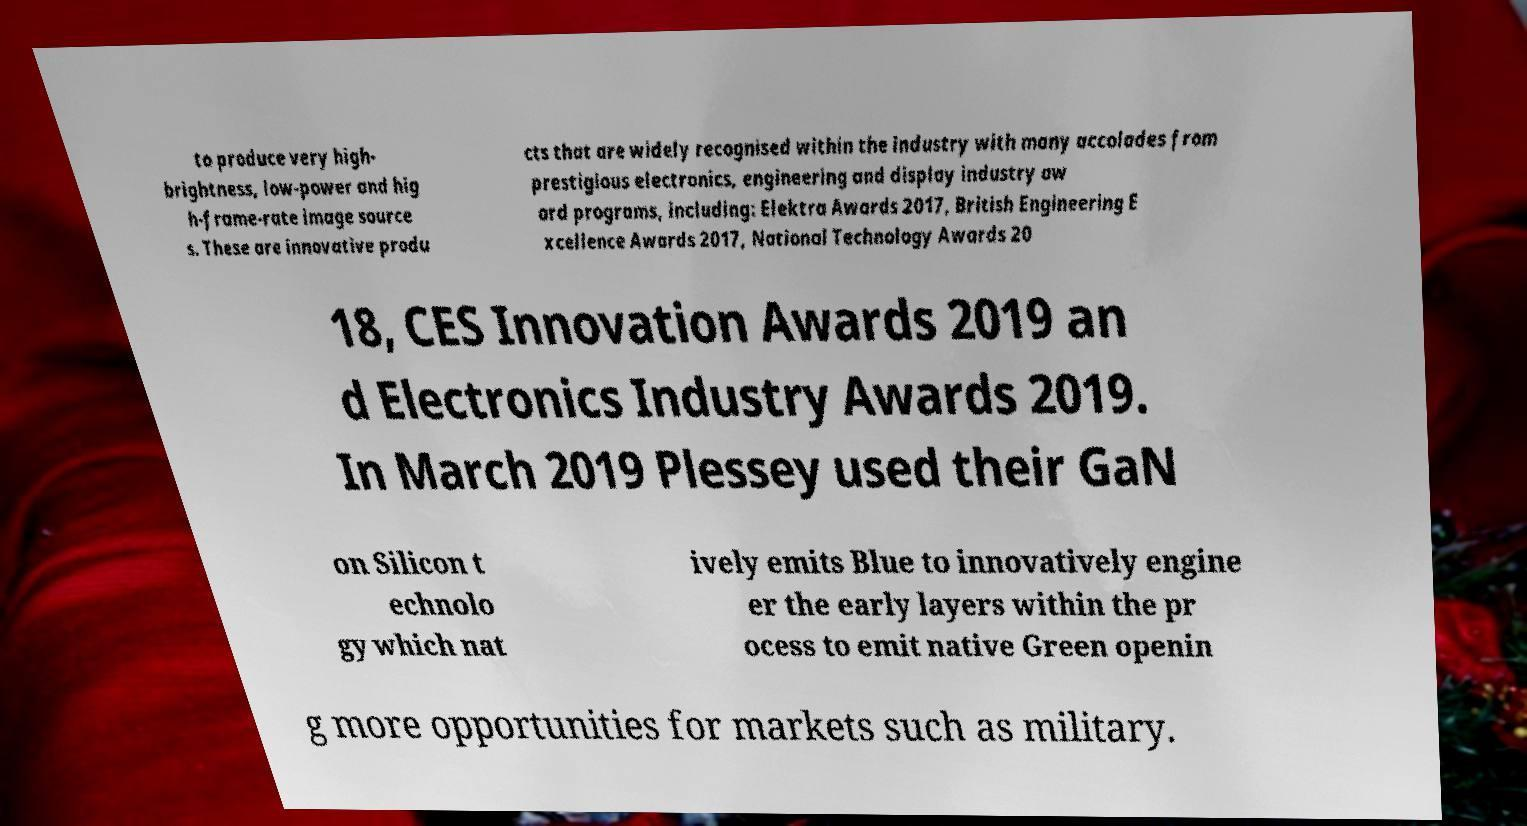For documentation purposes, I need the text within this image transcribed. Could you provide that? to produce very high- brightness, low-power and hig h-frame-rate image source s. These are innovative produ cts that are widely recognised within the industry with many accolades from prestigious electronics, engineering and display industry aw ard programs, including: Elektra Awards 2017, British Engineering E xcellence Awards 2017, National Technology Awards 20 18, CES Innovation Awards 2019 an d Electronics Industry Awards 2019. In March 2019 Plessey used their GaN on Silicon t echnolo gy which nat ively emits Blue to innovatively engine er the early layers within the pr ocess to emit native Green openin g more opportunities for markets such as military. 